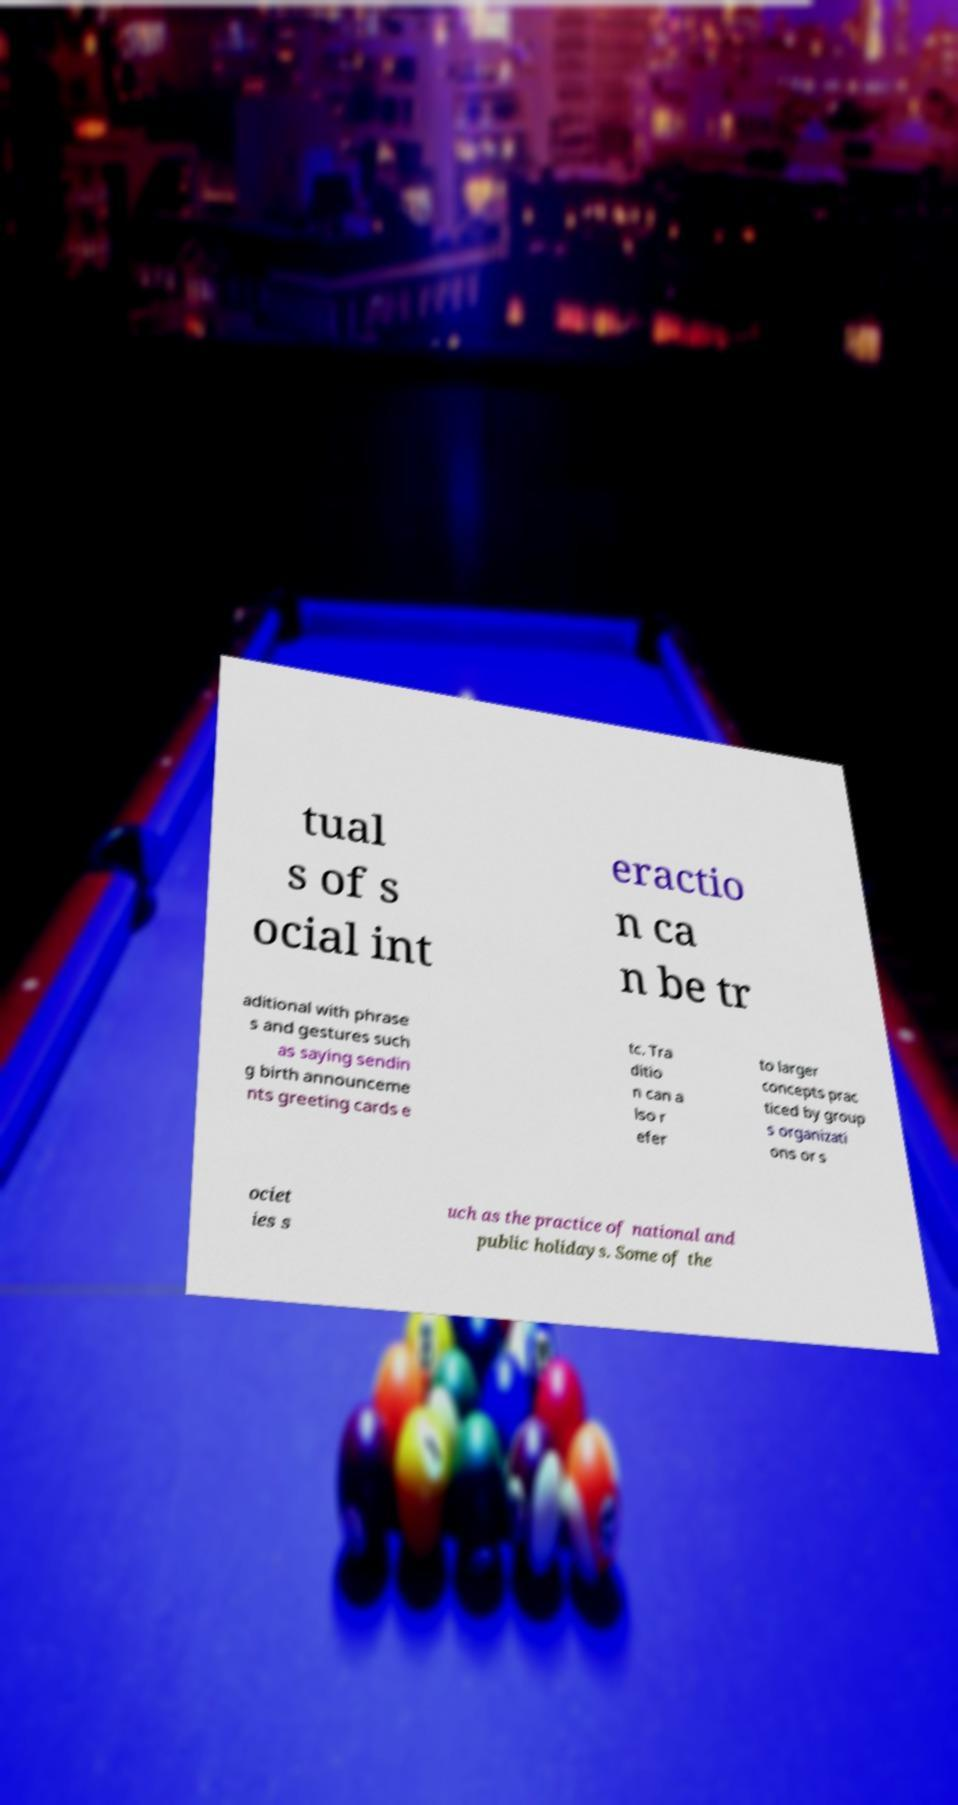There's text embedded in this image that I need extracted. Can you transcribe it verbatim? tual s of s ocial int eractio n ca n be tr aditional with phrase s and gestures such as saying sendin g birth announceme nts greeting cards e tc. Tra ditio n can a lso r efer to larger concepts prac ticed by group s organizati ons or s ociet ies s uch as the practice of national and public holidays. Some of the 